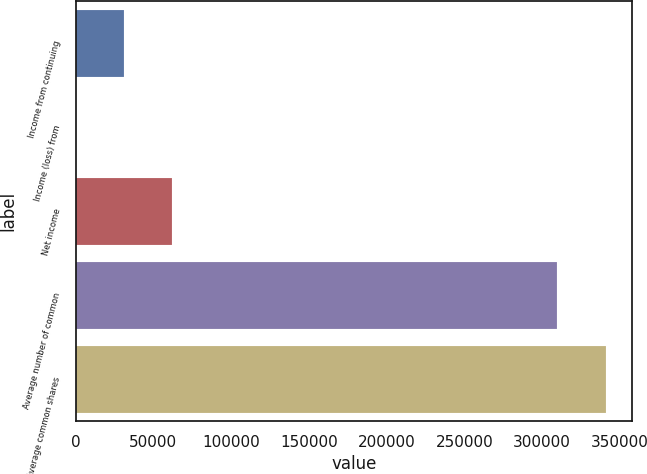Convert chart. <chart><loc_0><loc_0><loc_500><loc_500><bar_chart><fcel>Income from continuing<fcel>Income (loss) from<fcel>Net income<fcel>Average number of common<fcel>Average common shares<nl><fcel>30998.7<fcel>4<fcel>61993.4<fcel>309792<fcel>340787<nl></chart> 